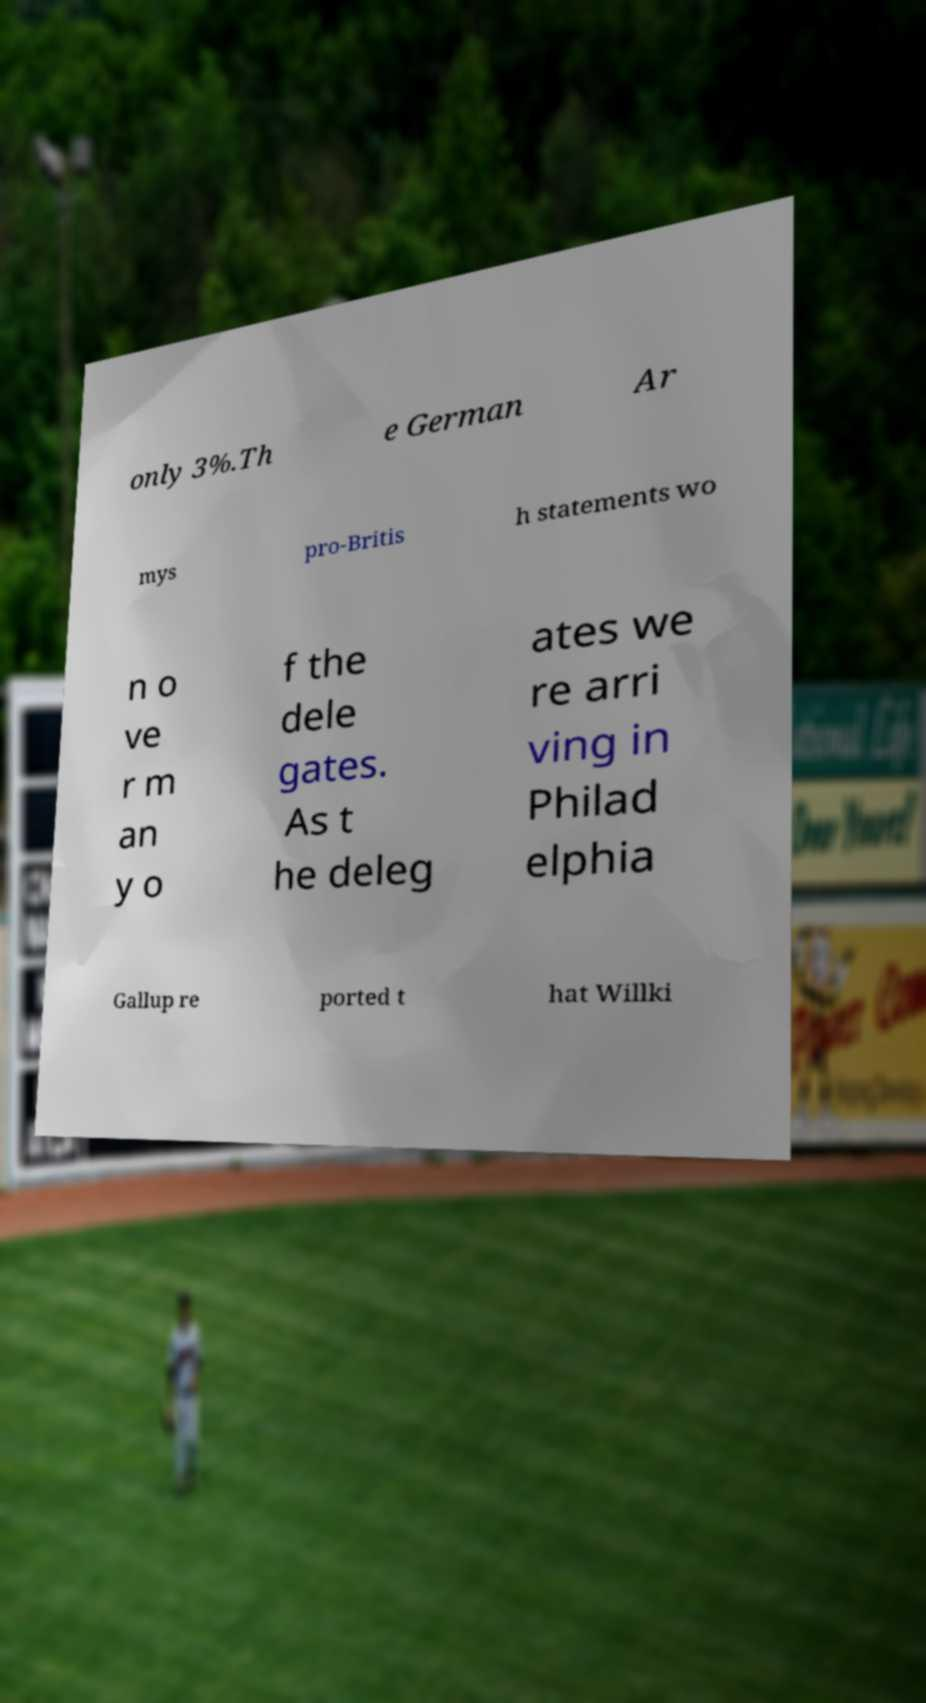There's text embedded in this image that I need extracted. Can you transcribe it verbatim? only 3%.Th e German Ar mys pro-Britis h statements wo n o ve r m an y o f the dele gates. As t he deleg ates we re arri ving in Philad elphia Gallup re ported t hat Willki 